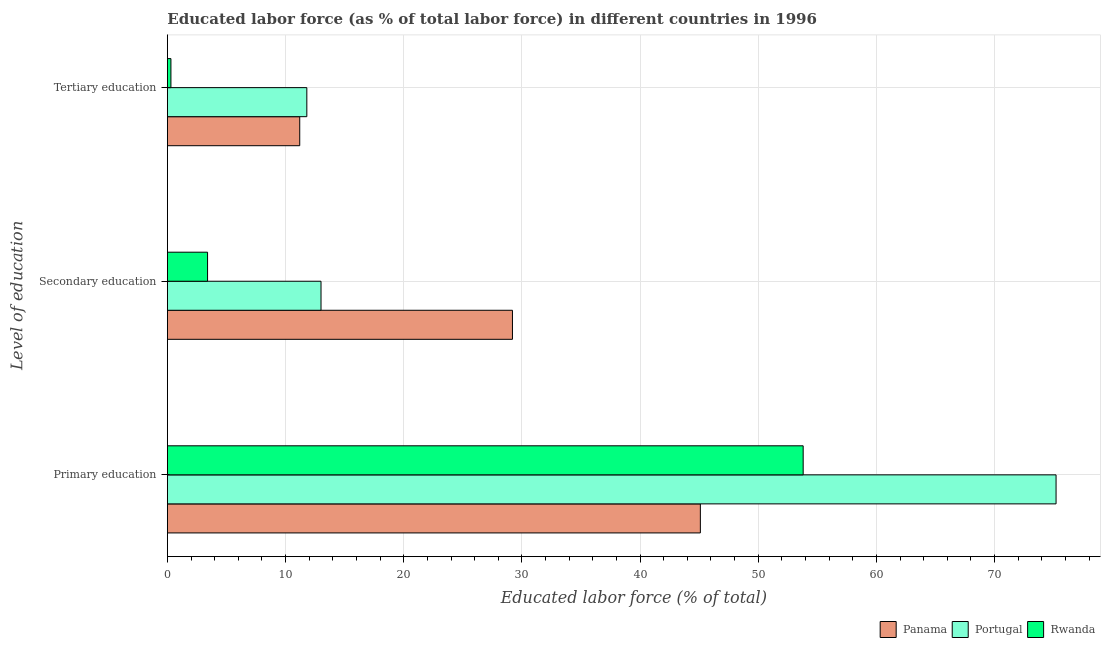How many different coloured bars are there?
Provide a succinct answer. 3. Are the number of bars per tick equal to the number of legend labels?
Ensure brevity in your answer.  Yes. What is the label of the 2nd group of bars from the top?
Give a very brief answer. Secondary education. What is the percentage of labor force who received primary education in Panama?
Provide a succinct answer. 45.1. Across all countries, what is the maximum percentage of labor force who received secondary education?
Your answer should be very brief. 29.2. Across all countries, what is the minimum percentage of labor force who received tertiary education?
Keep it short and to the point. 0.3. In which country was the percentage of labor force who received tertiary education maximum?
Your response must be concise. Portugal. In which country was the percentage of labor force who received tertiary education minimum?
Offer a very short reply. Rwanda. What is the total percentage of labor force who received secondary education in the graph?
Your response must be concise. 45.6. What is the difference between the percentage of labor force who received secondary education in Panama and that in Rwanda?
Your response must be concise. 25.8. What is the difference between the percentage of labor force who received primary education in Rwanda and the percentage of labor force who received tertiary education in Panama?
Provide a short and direct response. 42.6. What is the average percentage of labor force who received secondary education per country?
Your answer should be compact. 15.2. What is the difference between the percentage of labor force who received primary education and percentage of labor force who received tertiary education in Panama?
Your response must be concise. 33.9. In how many countries, is the percentage of labor force who received primary education greater than 66 %?
Make the answer very short. 1. What is the ratio of the percentage of labor force who received secondary education in Rwanda to that in Panama?
Provide a succinct answer. 0.12. Is the percentage of labor force who received tertiary education in Rwanda less than that in Portugal?
Your answer should be very brief. Yes. What is the difference between the highest and the second highest percentage of labor force who received tertiary education?
Your answer should be compact. 0.6. What is the difference between the highest and the lowest percentage of labor force who received secondary education?
Your answer should be compact. 25.8. In how many countries, is the percentage of labor force who received primary education greater than the average percentage of labor force who received primary education taken over all countries?
Offer a very short reply. 1. What does the 2nd bar from the top in Secondary education represents?
Provide a succinct answer. Portugal. What does the 2nd bar from the bottom in Secondary education represents?
Give a very brief answer. Portugal. Is it the case that in every country, the sum of the percentage of labor force who received primary education and percentage of labor force who received secondary education is greater than the percentage of labor force who received tertiary education?
Ensure brevity in your answer.  Yes. How many bars are there?
Keep it short and to the point. 9. Are all the bars in the graph horizontal?
Give a very brief answer. Yes. How many countries are there in the graph?
Give a very brief answer. 3. What is the difference between two consecutive major ticks on the X-axis?
Offer a very short reply. 10. Does the graph contain any zero values?
Provide a succinct answer. No. Where does the legend appear in the graph?
Give a very brief answer. Bottom right. How are the legend labels stacked?
Your answer should be very brief. Horizontal. What is the title of the graph?
Your answer should be compact. Educated labor force (as % of total labor force) in different countries in 1996. What is the label or title of the X-axis?
Your answer should be compact. Educated labor force (% of total). What is the label or title of the Y-axis?
Your answer should be very brief. Level of education. What is the Educated labor force (% of total) of Panama in Primary education?
Give a very brief answer. 45.1. What is the Educated labor force (% of total) in Portugal in Primary education?
Give a very brief answer. 75.2. What is the Educated labor force (% of total) in Rwanda in Primary education?
Your answer should be very brief. 53.8. What is the Educated labor force (% of total) of Panama in Secondary education?
Give a very brief answer. 29.2. What is the Educated labor force (% of total) in Rwanda in Secondary education?
Give a very brief answer. 3.4. What is the Educated labor force (% of total) in Panama in Tertiary education?
Provide a succinct answer. 11.2. What is the Educated labor force (% of total) in Portugal in Tertiary education?
Offer a very short reply. 11.8. What is the Educated labor force (% of total) of Rwanda in Tertiary education?
Offer a very short reply. 0.3. Across all Level of education, what is the maximum Educated labor force (% of total) of Panama?
Keep it short and to the point. 45.1. Across all Level of education, what is the maximum Educated labor force (% of total) of Portugal?
Your answer should be very brief. 75.2. Across all Level of education, what is the maximum Educated labor force (% of total) of Rwanda?
Give a very brief answer. 53.8. Across all Level of education, what is the minimum Educated labor force (% of total) in Panama?
Your answer should be compact. 11.2. Across all Level of education, what is the minimum Educated labor force (% of total) of Portugal?
Your response must be concise. 11.8. Across all Level of education, what is the minimum Educated labor force (% of total) in Rwanda?
Your response must be concise. 0.3. What is the total Educated labor force (% of total) of Panama in the graph?
Ensure brevity in your answer.  85.5. What is the total Educated labor force (% of total) of Portugal in the graph?
Your answer should be compact. 100. What is the total Educated labor force (% of total) in Rwanda in the graph?
Provide a short and direct response. 57.5. What is the difference between the Educated labor force (% of total) of Portugal in Primary education and that in Secondary education?
Make the answer very short. 62.2. What is the difference between the Educated labor force (% of total) in Rwanda in Primary education and that in Secondary education?
Your answer should be very brief. 50.4. What is the difference between the Educated labor force (% of total) of Panama in Primary education and that in Tertiary education?
Provide a short and direct response. 33.9. What is the difference between the Educated labor force (% of total) of Portugal in Primary education and that in Tertiary education?
Offer a terse response. 63.4. What is the difference between the Educated labor force (% of total) of Rwanda in Primary education and that in Tertiary education?
Provide a succinct answer. 53.5. What is the difference between the Educated labor force (% of total) in Panama in Secondary education and that in Tertiary education?
Give a very brief answer. 18. What is the difference between the Educated labor force (% of total) in Rwanda in Secondary education and that in Tertiary education?
Ensure brevity in your answer.  3.1. What is the difference between the Educated labor force (% of total) of Panama in Primary education and the Educated labor force (% of total) of Portugal in Secondary education?
Provide a succinct answer. 32.1. What is the difference between the Educated labor force (% of total) of Panama in Primary education and the Educated labor force (% of total) of Rwanda in Secondary education?
Provide a short and direct response. 41.7. What is the difference between the Educated labor force (% of total) of Portugal in Primary education and the Educated labor force (% of total) of Rwanda in Secondary education?
Offer a very short reply. 71.8. What is the difference between the Educated labor force (% of total) of Panama in Primary education and the Educated labor force (% of total) of Portugal in Tertiary education?
Your answer should be very brief. 33.3. What is the difference between the Educated labor force (% of total) in Panama in Primary education and the Educated labor force (% of total) in Rwanda in Tertiary education?
Your response must be concise. 44.8. What is the difference between the Educated labor force (% of total) in Portugal in Primary education and the Educated labor force (% of total) in Rwanda in Tertiary education?
Make the answer very short. 74.9. What is the difference between the Educated labor force (% of total) in Panama in Secondary education and the Educated labor force (% of total) in Portugal in Tertiary education?
Ensure brevity in your answer.  17.4. What is the difference between the Educated labor force (% of total) in Panama in Secondary education and the Educated labor force (% of total) in Rwanda in Tertiary education?
Offer a terse response. 28.9. What is the difference between the Educated labor force (% of total) in Portugal in Secondary education and the Educated labor force (% of total) in Rwanda in Tertiary education?
Offer a very short reply. 12.7. What is the average Educated labor force (% of total) of Panama per Level of education?
Make the answer very short. 28.5. What is the average Educated labor force (% of total) of Portugal per Level of education?
Make the answer very short. 33.33. What is the average Educated labor force (% of total) of Rwanda per Level of education?
Give a very brief answer. 19.17. What is the difference between the Educated labor force (% of total) of Panama and Educated labor force (% of total) of Portugal in Primary education?
Your response must be concise. -30.1. What is the difference between the Educated labor force (% of total) of Portugal and Educated labor force (% of total) of Rwanda in Primary education?
Offer a very short reply. 21.4. What is the difference between the Educated labor force (% of total) in Panama and Educated labor force (% of total) in Rwanda in Secondary education?
Your answer should be very brief. 25.8. What is the difference between the Educated labor force (% of total) in Panama and Educated labor force (% of total) in Rwanda in Tertiary education?
Provide a succinct answer. 10.9. What is the ratio of the Educated labor force (% of total) in Panama in Primary education to that in Secondary education?
Ensure brevity in your answer.  1.54. What is the ratio of the Educated labor force (% of total) of Portugal in Primary education to that in Secondary education?
Your answer should be compact. 5.78. What is the ratio of the Educated labor force (% of total) in Rwanda in Primary education to that in Secondary education?
Offer a very short reply. 15.82. What is the ratio of the Educated labor force (% of total) in Panama in Primary education to that in Tertiary education?
Offer a terse response. 4.03. What is the ratio of the Educated labor force (% of total) in Portugal in Primary education to that in Tertiary education?
Ensure brevity in your answer.  6.37. What is the ratio of the Educated labor force (% of total) in Rwanda in Primary education to that in Tertiary education?
Provide a succinct answer. 179.33. What is the ratio of the Educated labor force (% of total) in Panama in Secondary education to that in Tertiary education?
Provide a succinct answer. 2.61. What is the ratio of the Educated labor force (% of total) of Portugal in Secondary education to that in Tertiary education?
Provide a succinct answer. 1.1. What is the ratio of the Educated labor force (% of total) in Rwanda in Secondary education to that in Tertiary education?
Make the answer very short. 11.33. What is the difference between the highest and the second highest Educated labor force (% of total) of Portugal?
Give a very brief answer. 62.2. What is the difference between the highest and the second highest Educated labor force (% of total) in Rwanda?
Your answer should be compact. 50.4. What is the difference between the highest and the lowest Educated labor force (% of total) in Panama?
Keep it short and to the point. 33.9. What is the difference between the highest and the lowest Educated labor force (% of total) of Portugal?
Keep it short and to the point. 63.4. What is the difference between the highest and the lowest Educated labor force (% of total) in Rwanda?
Offer a very short reply. 53.5. 